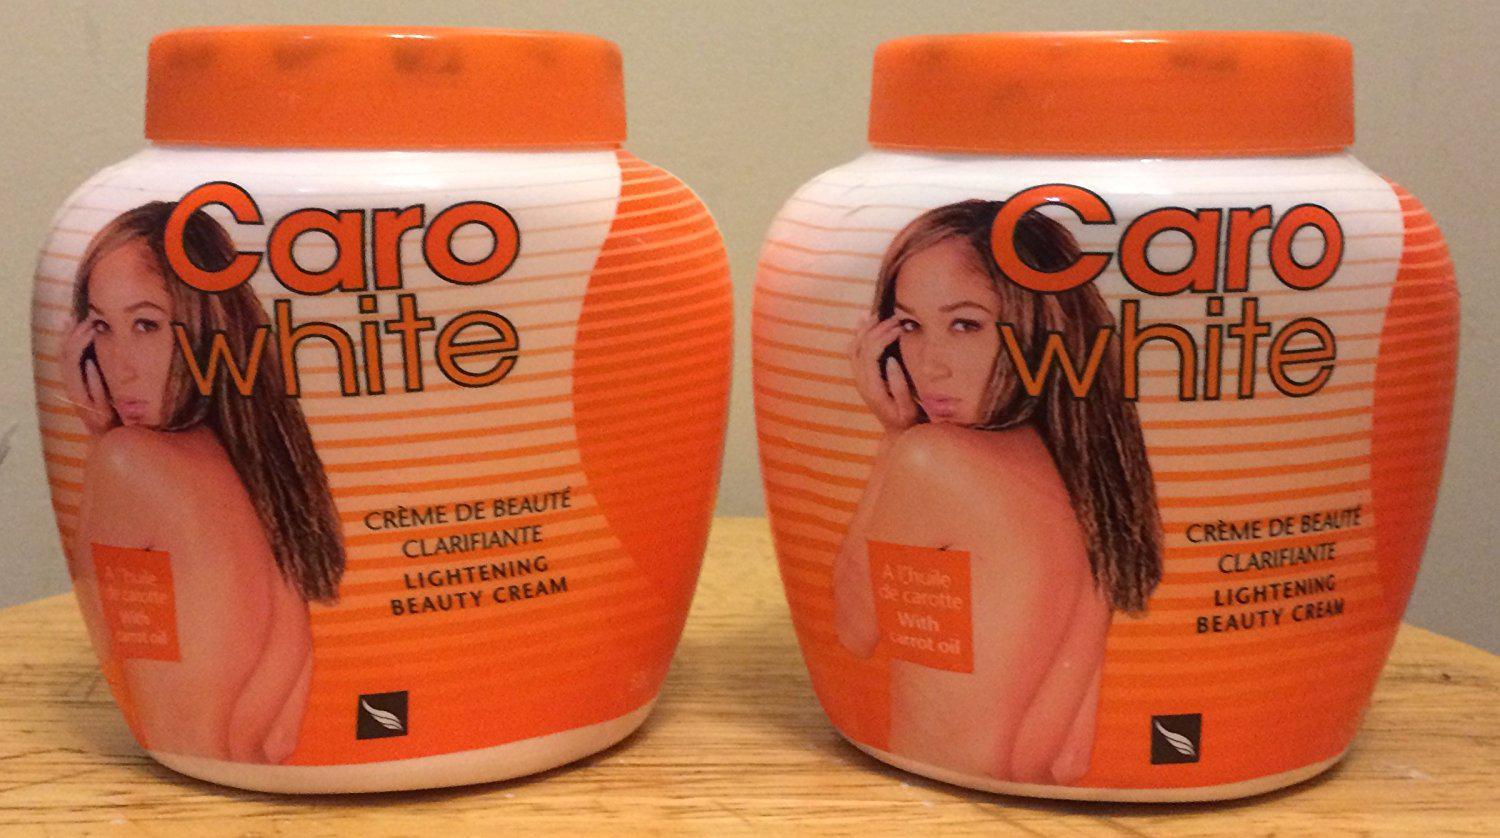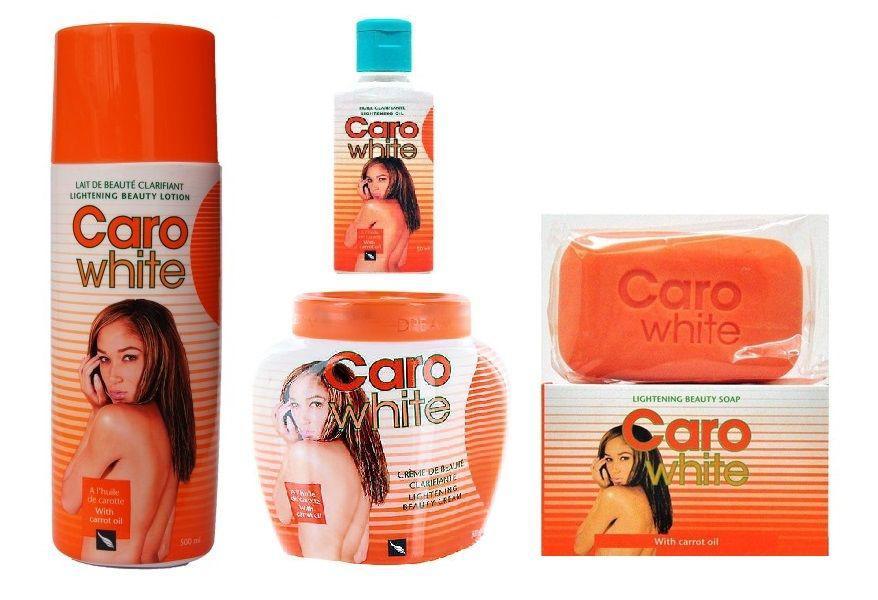The first image is the image on the left, the second image is the image on the right. Evaluate the accuracy of this statement regarding the images: "Each image includes a squat, roundish jar with a flat orange lid, and at least one image also includes a cylinder-shaped bottle and orange cap, and a bottle with a blue cap.". Is it true? Answer yes or no. Yes. The first image is the image on the left, the second image is the image on the right. Considering the images on both sides, is "One product is sitting on its box." valid? Answer yes or no. Yes. 